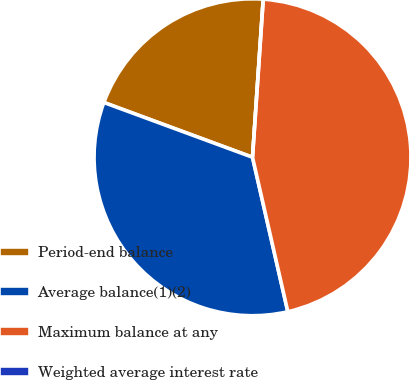<chart> <loc_0><loc_0><loc_500><loc_500><pie_chart><fcel>Period-end balance<fcel>Average balance(1)(2)<fcel>Maximum balance at any<fcel>Weighted average interest rate<nl><fcel>20.46%<fcel>34.2%<fcel>45.35%<fcel>0.0%<nl></chart> 